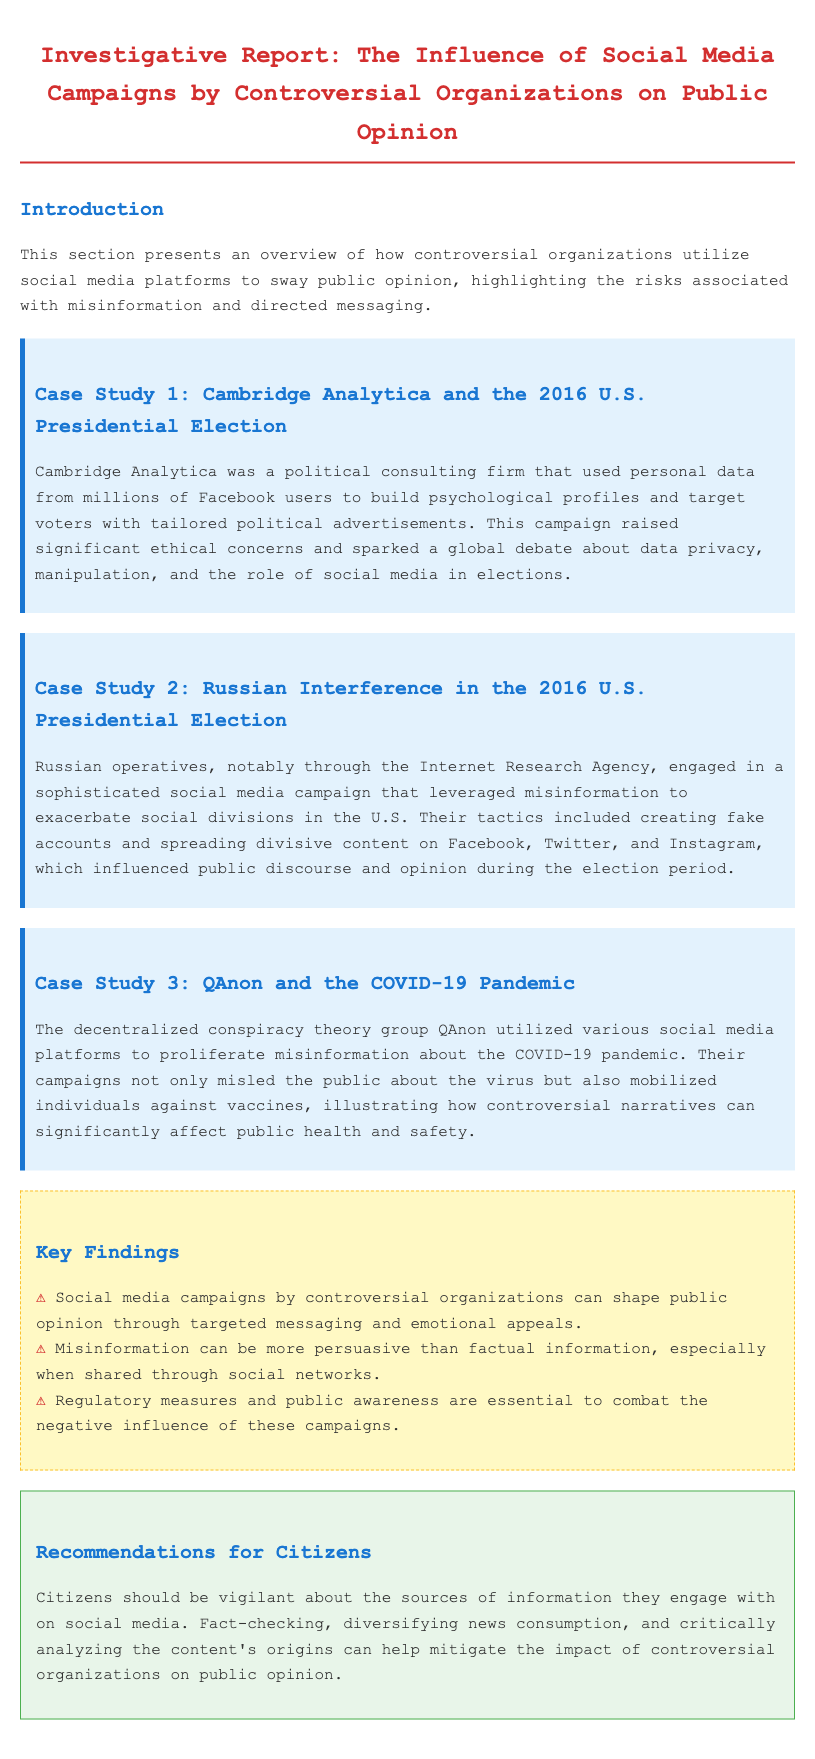What is the title of the report? The title is prominently displayed at the top of the document, which is focused on social media campaigns and public opinion.
Answer: Investigative Report: The Influence of Social Media Campaigns by Controversial Organizations on Public Opinion Who conducted the case study related to the 2016 U.S. Presidential Election? The document explicitly mentions Cambridge Analytica in the first case study.
Answer: Cambridge Analytica What did Russian operatives use to influence public opinion? The document details the use of a sophisticated social media campaign through specific entities.
Answer: Misinformation How many case studies are presented in the report? The report lists three distinct case studies, each addressing different organizations and events.
Answer: Three What is identified as essential to combat negative influences on public opinion? The report emphasizes the need for certain actions in the key findings section to mitigate negative influence.
Answer: Regulatory measures and public awareness What conspiracy theory group proliferated misinformation about COVID-19? The third case study clearly states the name of the group involved.
Answer: QAnon What should citizens do regarding the sources of information on social media? The recommendations section advises citizens to engage in specific behaviors related to their media consumption.
Answer: Be vigilant What are the emotional tactics used by controversial organizations? The key findings section highlights the method used by these organizations to shape public views.
Answer: Emotional appeals 